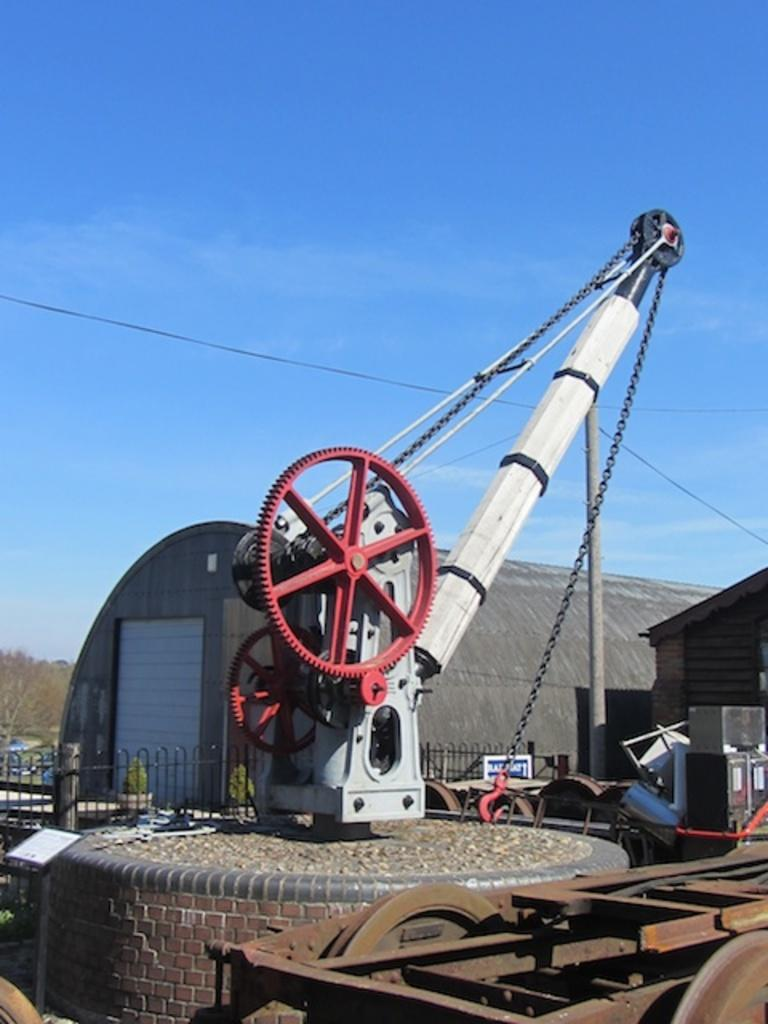What type of machine is visible in the image? There is a machine in the image that resembles a crane. What safety feature is present in front of the machine? There are railings in front of the machine. What type of structures can be seen in the background of the image? There are houses visible in the image. What material is used to construct the machine and railings? There are metal objects present in the image. Can you see any branches on the machine in the image? There are no branches present on the machine in the image. What type of fruit is being supported by the railings in the image? There are no fruits, including quinces, present in the image. 